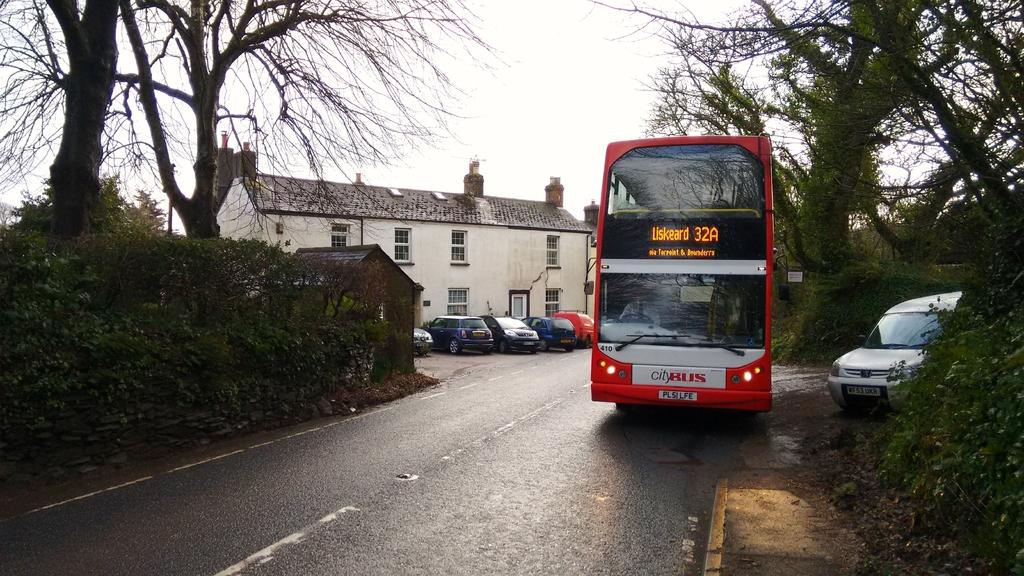How many vehicles can be seen on the road in the image? There are two vehicles on the road in the image. What else is present in the image besides the vehicles? There is a plant, a building, a tree, and the sky visible in the image. Can you describe the building in the image? The building has windows. What type of vegetation is present in the image? There is a tree and a plant in the image. What is visible at the top of the image? The sky is visible in the image. What can be seen on the road in the image? There is a road with white lines in the image. Where is the father in the image? There is no father present in the image. What type of fruit is hanging from the tree in the image? There is no fruit visible on the tree in the image. 